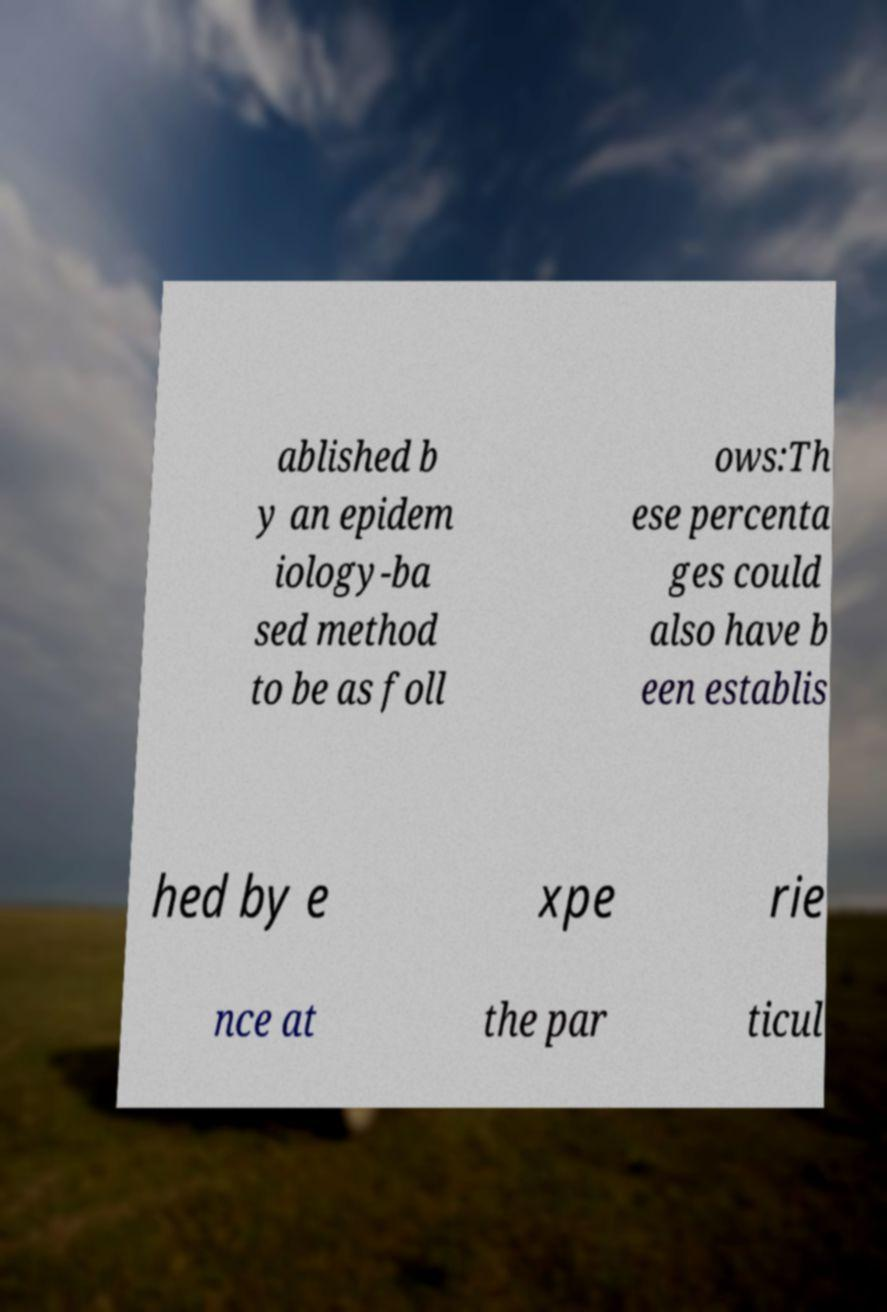Please identify and transcribe the text found in this image. ablished b y an epidem iology-ba sed method to be as foll ows:Th ese percenta ges could also have b een establis hed by e xpe rie nce at the par ticul 